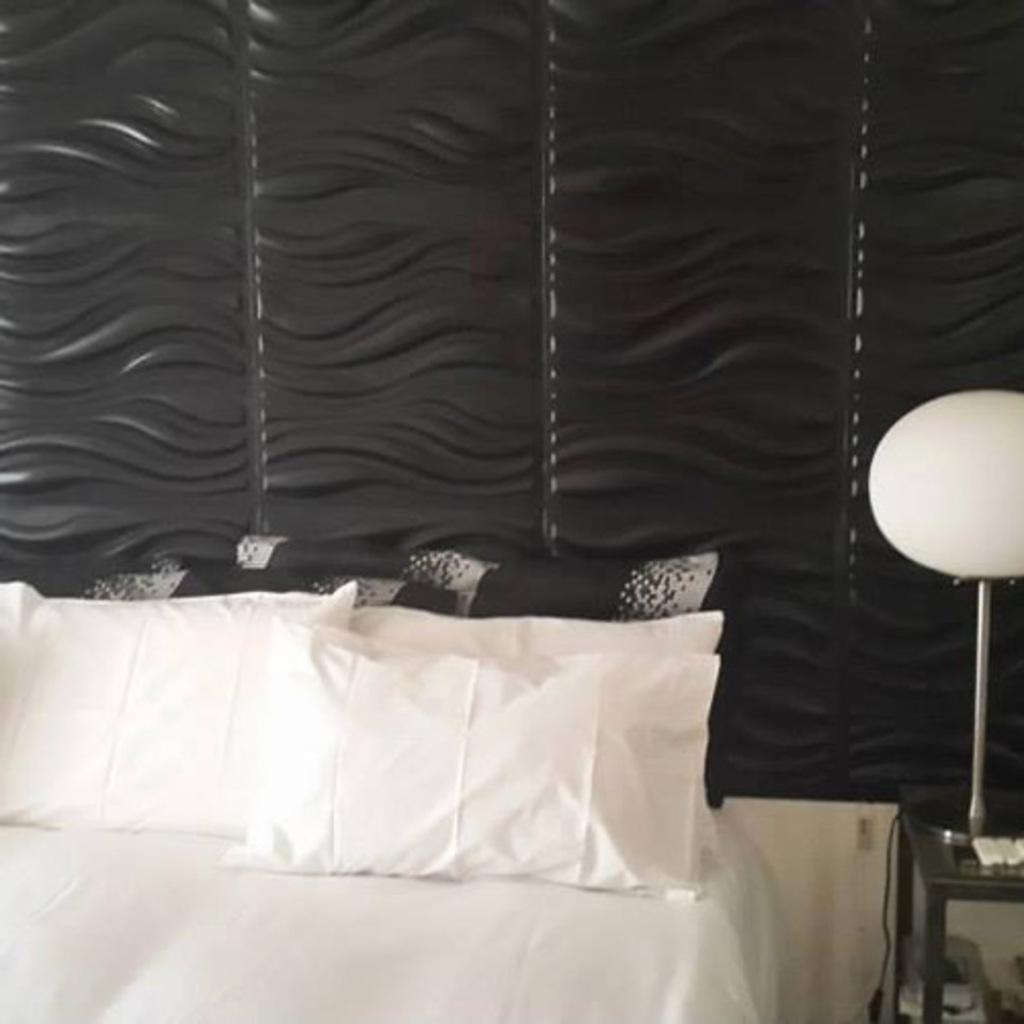What is located at the bottom of the image? There is a bed at the bottom of the image. What can be seen on the bed? There are white-colored pillows on the bed. Where is the lamp positioned in the image? The lamp is on the right side of the image. What color is present on the wall in the middle of the image? There is a black color on the wall in the middle of the image. What type of appliance is being used for a haircut in the image? There is no appliance or haircut present in the image. What is the condition of the roof in the image? There is no roof present in the image; it is an interior scene with a bed, pillows, a lamp, and a wall. 